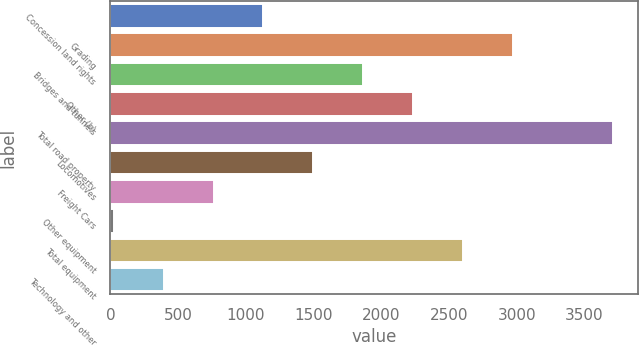<chart> <loc_0><loc_0><loc_500><loc_500><bar_chart><fcel>Concession land rights<fcel>Grading<fcel>Bridges and tunnels<fcel>Other (b)<fcel>Total road property<fcel>Locomotives<fcel>Freight Cars<fcel>Other equipment<fcel>Total equipment<fcel>Technology and other<nl><fcel>1129.8<fcel>2970.3<fcel>1866<fcel>2234.1<fcel>3706.5<fcel>1497.9<fcel>761.7<fcel>25.5<fcel>2602.2<fcel>393.6<nl></chart> 